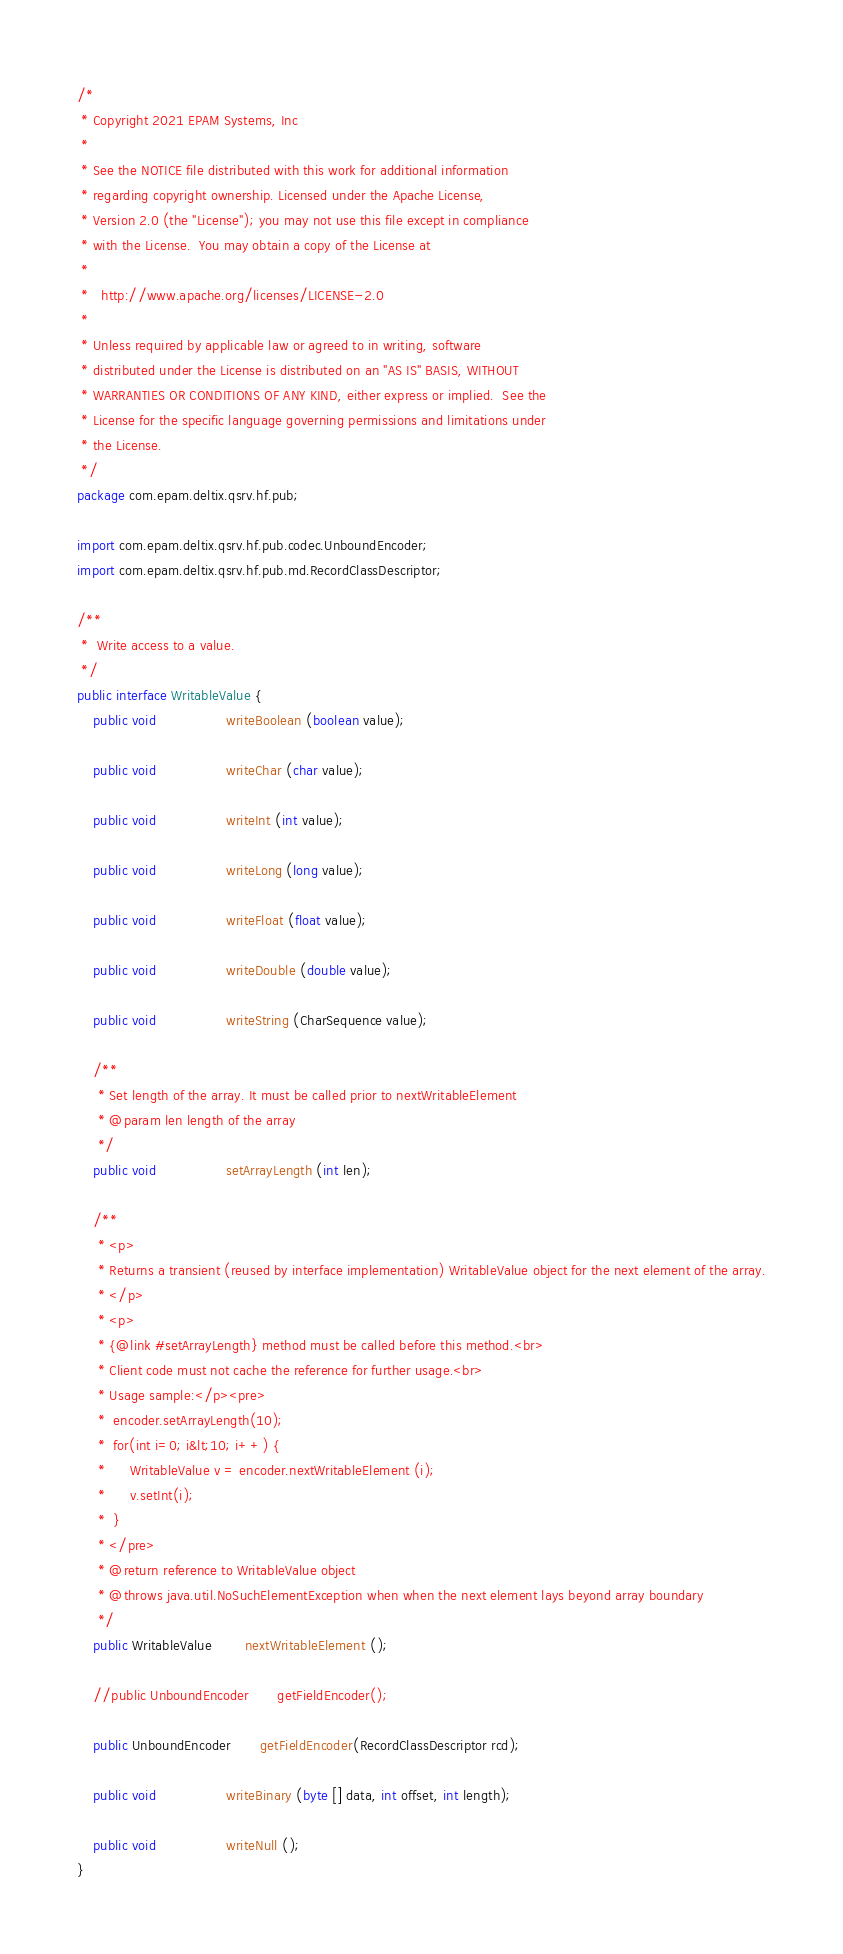<code> <loc_0><loc_0><loc_500><loc_500><_Java_>/*
 * Copyright 2021 EPAM Systems, Inc
 *
 * See the NOTICE file distributed with this work for additional information
 * regarding copyright ownership. Licensed under the Apache License,
 * Version 2.0 (the "License"); you may not use this file except in compliance
 * with the License.  You may obtain a copy of the License at
 *
 *   http://www.apache.org/licenses/LICENSE-2.0
 *
 * Unless required by applicable law or agreed to in writing, software
 * distributed under the License is distributed on an "AS IS" BASIS, WITHOUT
 * WARRANTIES OR CONDITIONS OF ANY KIND, either express or implied.  See the
 * License for the specific language governing permissions and limitations under
 * the License.
 */
package com.epam.deltix.qsrv.hf.pub;

import com.epam.deltix.qsrv.hf.pub.codec.UnboundEncoder;
import com.epam.deltix.qsrv.hf.pub.md.RecordClassDescriptor;

/**
 *  Write access to a value.
 */
public interface WritableValue {
    public void                 writeBoolean (boolean value);

    public void                 writeChar (char value);

    public void                 writeInt (int value);

    public void                 writeLong (long value);

    public void                 writeFloat (float value);

    public void                 writeDouble (double value);

    public void                 writeString (CharSequence value);

    /**
     * Set length of the array. It must be called prior to nextWritableElement
     * @param len length of the array
     */
    public void                 setArrayLength (int len);

    /**
     * <p>
     * Returns a transient (reused by interface implementation) WritableValue object for the next element of the array.
     * </p>
     * <p>
     * {@link #setArrayLength} method must be called before this method.<br>
     * Client code must not cache the reference for further usage.<br>
     * Usage sample:</p><pre>
     *  encoder.setArrayLength(10);
     *  for(int i=0; i&lt;10; i++) {
     *      WritableValue v = encoder.nextWritableElement (i);
     *      v.setInt(i);
     *  }
     * </pre>
     * @return reference to WritableValue object
     * @throws java.util.NoSuchElementException when when the next element lays beyond array boundary
     */
    public WritableValue        nextWritableElement ();

    //public UnboundEncoder       getFieldEncoder();

    public UnboundEncoder       getFieldEncoder(RecordClassDescriptor rcd);

    public void                 writeBinary (byte [] data, int offset, int length);

    public void                 writeNull ();
}
</code> 